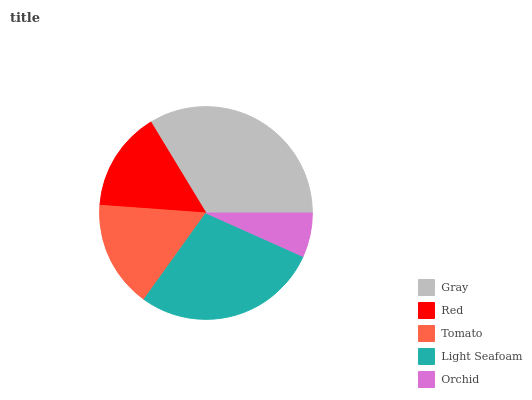Is Orchid the minimum?
Answer yes or no. Yes. Is Gray the maximum?
Answer yes or no. Yes. Is Red the minimum?
Answer yes or no. No. Is Red the maximum?
Answer yes or no. No. Is Gray greater than Red?
Answer yes or no. Yes. Is Red less than Gray?
Answer yes or no. Yes. Is Red greater than Gray?
Answer yes or no. No. Is Gray less than Red?
Answer yes or no. No. Is Tomato the high median?
Answer yes or no. Yes. Is Tomato the low median?
Answer yes or no. Yes. Is Gray the high median?
Answer yes or no. No. Is Orchid the low median?
Answer yes or no. No. 